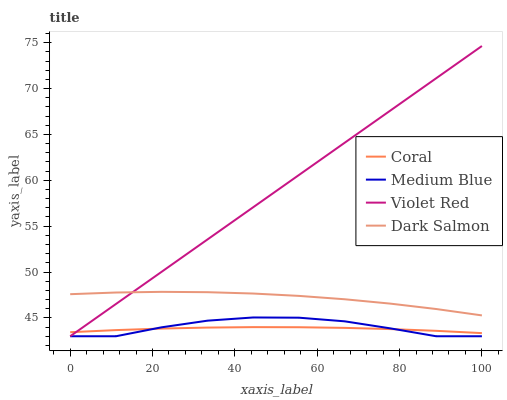Does Coral have the minimum area under the curve?
Answer yes or no. Yes. Does Violet Red have the maximum area under the curve?
Answer yes or no. Yes. Does Medium Blue have the minimum area under the curve?
Answer yes or no. No. Does Medium Blue have the maximum area under the curve?
Answer yes or no. No. Is Violet Red the smoothest?
Answer yes or no. Yes. Is Medium Blue the roughest?
Answer yes or no. Yes. Is Medium Blue the smoothest?
Answer yes or no. No. Is Violet Red the roughest?
Answer yes or no. No. Does Medium Blue have the lowest value?
Answer yes or no. Yes. Does Dark Salmon have the lowest value?
Answer yes or no. No. Does Violet Red have the highest value?
Answer yes or no. Yes. Does Medium Blue have the highest value?
Answer yes or no. No. Is Medium Blue less than Dark Salmon?
Answer yes or no. Yes. Is Dark Salmon greater than Coral?
Answer yes or no. Yes. Does Medium Blue intersect Violet Red?
Answer yes or no. Yes. Is Medium Blue less than Violet Red?
Answer yes or no. No. Is Medium Blue greater than Violet Red?
Answer yes or no. No. Does Medium Blue intersect Dark Salmon?
Answer yes or no. No. 